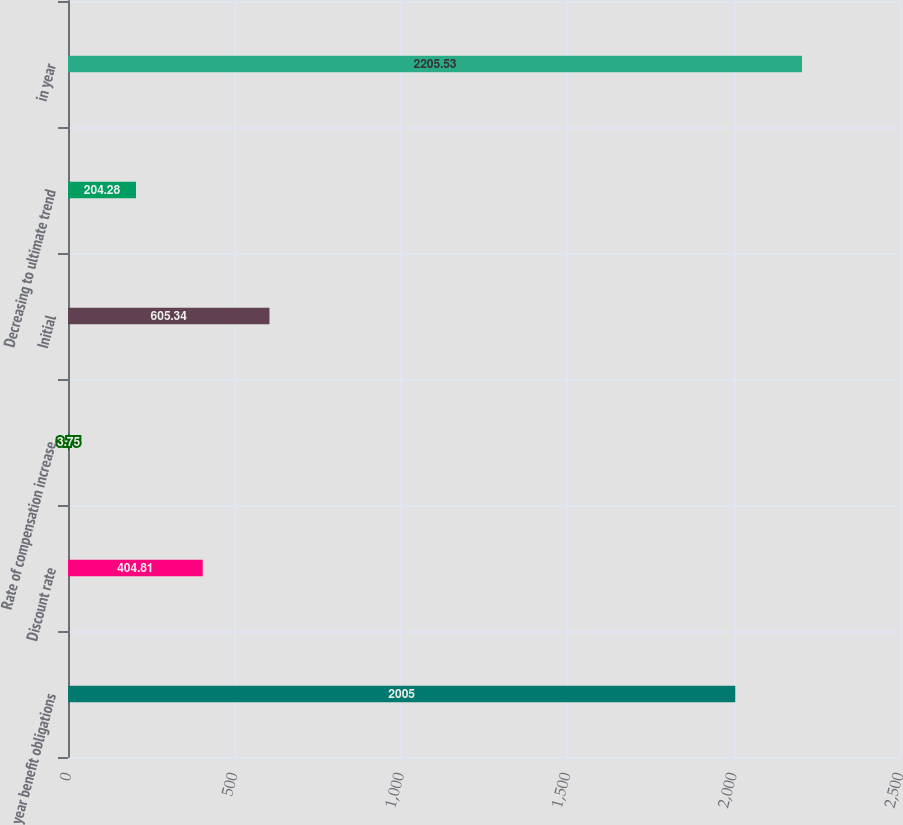<chart> <loc_0><loc_0><loc_500><loc_500><bar_chart><fcel>year benefit obligations<fcel>Discount rate<fcel>Rate of compensation increase<fcel>Initial<fcel>Decreasing to ultimate trend<fcel>in year<nl><fcel>2005<fcel>404.81<fcel>3.75<fcel>605.34<fcel>204.28<fcel>2205.53<nl></chart> 